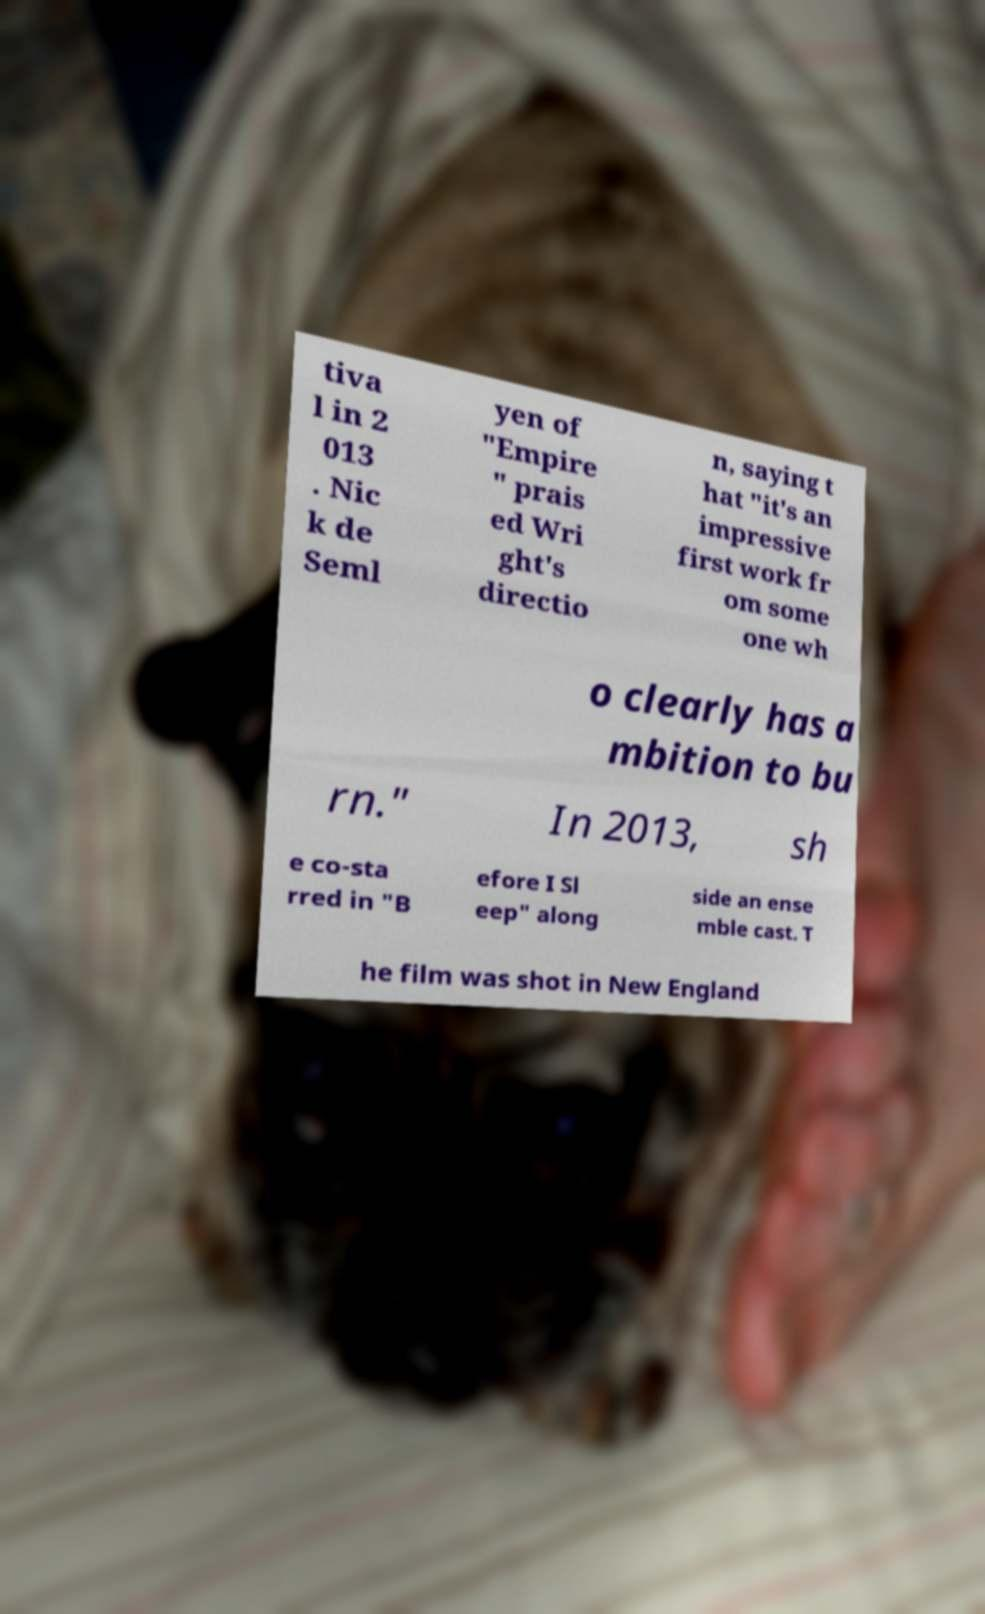There's text embedded in this image that I need extracted. Can you transcribe it verbatim? tiva l in 2 013 . Nic k de Seml yen of "Empire " prais ed Wri ght's directio n, saying t hat "it's an impressive first work fr om some one wh o clearly has a mbition to bu rn." In 2013, sh e co-sta rred in "B efore I Sl eep" along side an ense mble cast. T he film was shot in New England 